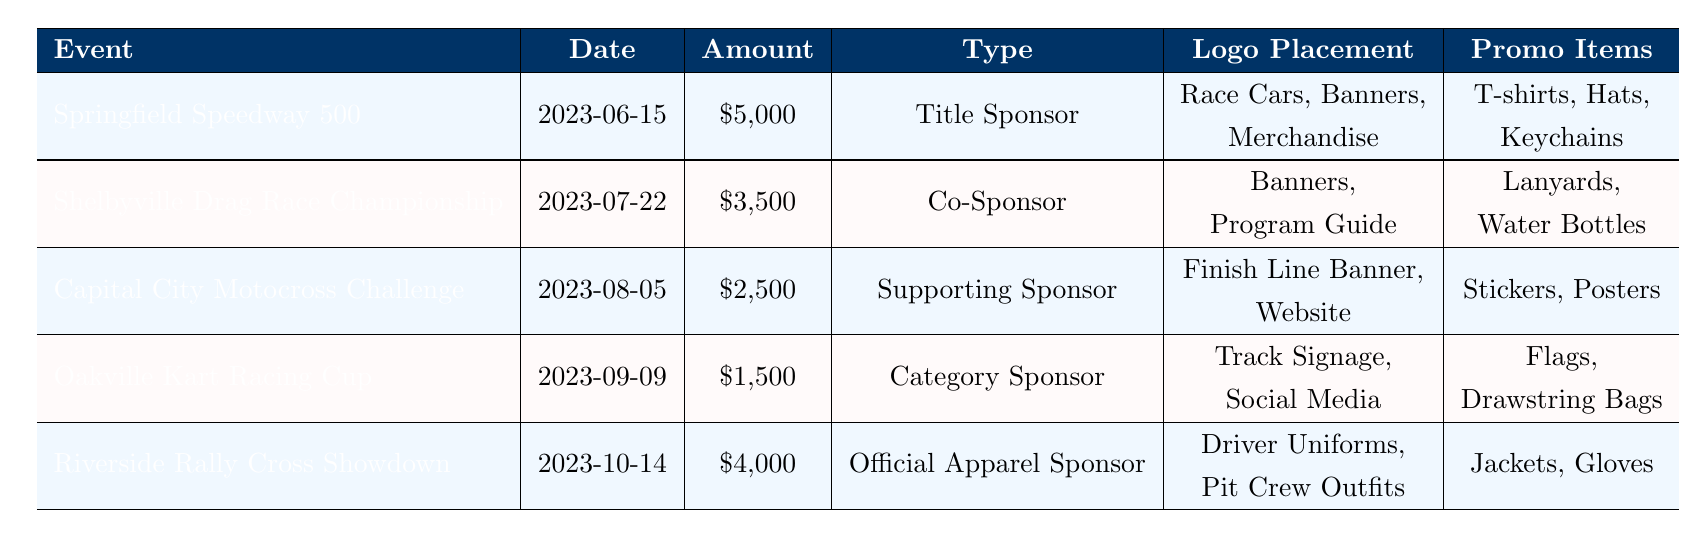What is the sponsorship amount for the Springfield Speedway 500? The table lists the Springfield Speedway 500 event with a sponsorship amount of $5,000.
Answer: $5,000 How many events are listed in the table? By counting the number of rows in the table, there are a total of 5 events listed.
Answer: 5 Which event has the highest sponsorship amount? The table shows the Springfield Speedway 500 has the highest sponsorship amount of $5,000 compared to the other events.
Answer: Springfield Speedway 500 What is the total sponsorship amount across all events? Adding the sponsorship amounts ($5,000 + $3,500 + $2,500 + $1,500 + $4,000) gives a total of $16,500.
Answer: $16,500 How many staff are required for the Riverside Rally Cross Showdown? The table indicates that 3 staff members are required for the Riverside Rally Cross Showdown event.
Answer: 3 Is the Oakville Kart Racing Cup a title sponsor event? The Oakville Kart Racing Cup is categorized as a Category Sponsor, so it is not a title sponsor event.
Answer: No What promotional items are given for the Capital City Motocross Challenge? The promotional items for the Capital City Motocross Challenge are stickers and posters, as listed in the table.
Answer: Stickers, Posters Which event requires the least booth size? The events Shelbyville Drag Race Championship and Oakville Kart Racing Cup both require a booth size of 10x10 ft, which is the smallest listed.
Answer: Shelbyville Drag Race Championship, Oakville Kart Racing Cup What is the average sponsorship amount for all the events? The total sponsorship amount is $16,500, and with 5 events, the average is calculated as $16,500 / 5 = $3,300.
Answer: $3,300 How much more funding was allocated to the Title Sponsor than the Category Sponsor? The Title Sponsor (Springfield Speedway 500) has $5,000 and the Category Sponsor (Oakville Kart Racing Cup) has $1,500. The difference is $5,000 - $1,500 = $3,500.
Answer: $3,500 